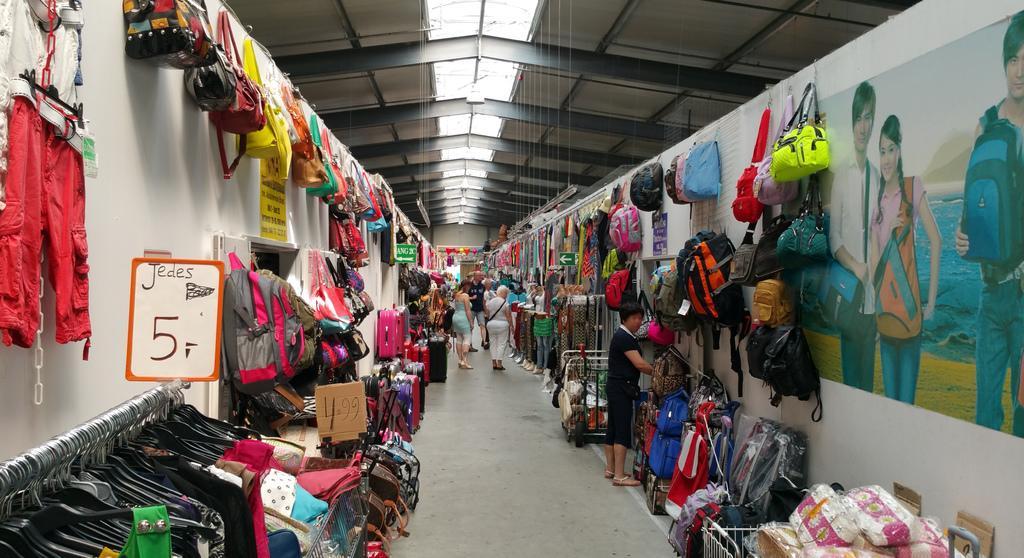Can you describe this image briefly? On the right side there is a wall. On the wall there is a poster. Also there are many bags hanged on the wall. Near to the wall there are baskets. On the baskets there are many bags. On the left side there is a wall. On the wall there are dresses, bags. On the hangers there are dresses. On the ceiling there are lights. In the back there are people and many other items. 